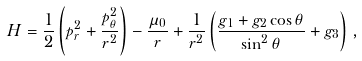<formula> <loc_0><loc_0><loc_500><loc_500>H = \frac { 1 } { 2 } \left ( p _ { r } ^ { 2 } + \frac { p _ { \theta } ^ { 2 } } { r ^ { 2 } } \right ) - \frac { \mu _ { 0 } } { r } + \frac { 1 } { r ^ { 2 } } \left ( \frac { g _ { 1 } + g _ { 2 } \cos \theta } { \sin ^ { 2 } \theta } + g _ { 3 } \right ) \, ,</formula> 